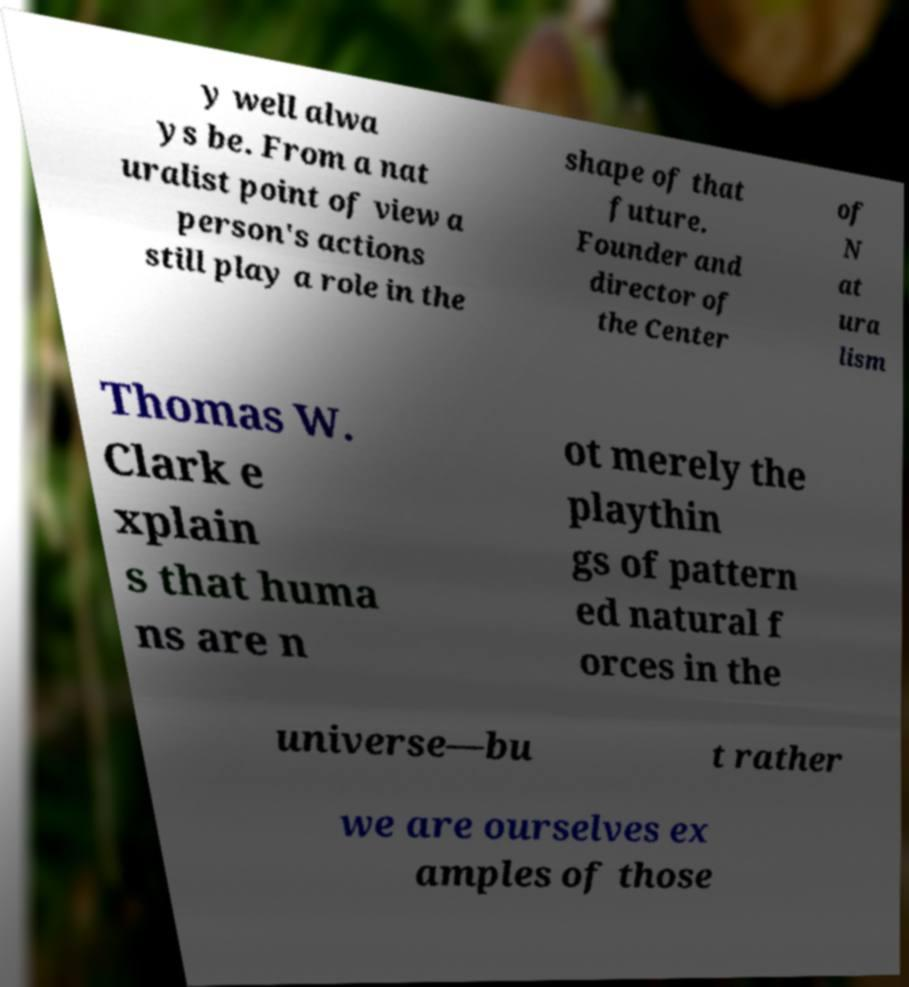Could you extract and type out the text from this image? y well alwa ys be. From a nat uralist point of view a person's actions still play a role in the shape of that future. Founder and director of the Center of N at ura lism Thomas W. Clark e xplain s that huma ns are n ot merely the playthin gs of pattern ed natural f orces in the universe—bu t rather we are ourselves ex amples of those 